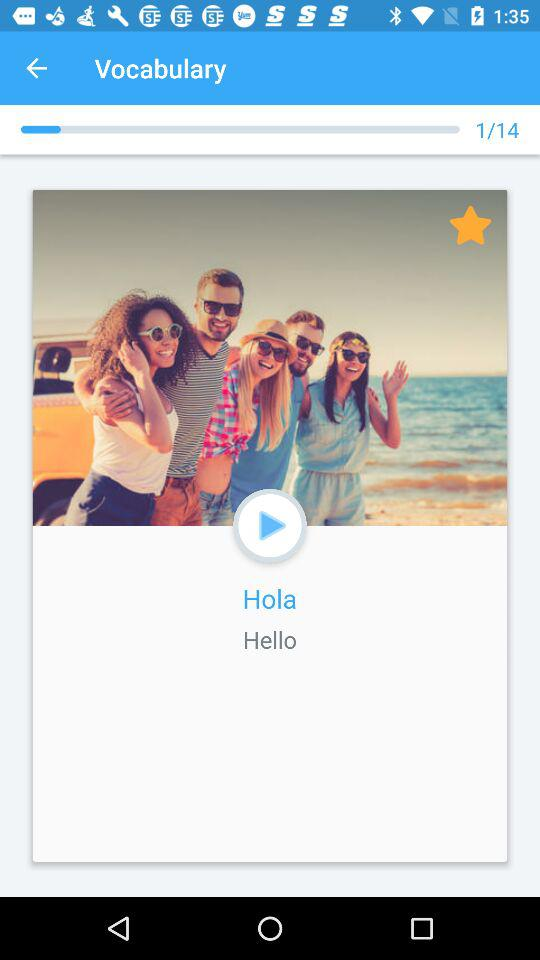What is the word? The words are "Hola" and "Hello". 